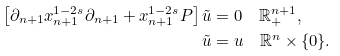<formula> <loc_0><loc_0><loc_500><loc_500>\left [ \partial _ { n + 1 } x _ { n + 1 } ^ { 1 - 2 s } \partial _ { n + 1 } + x _ { n + 1 } ^ { 1 - 2 s } P \right ] \tilde { u } & = 0 \quad \mathbb { R } _ { + } ^ { n + 1 } , \\ \tilde { u } & = u \quad \mathbb { R } ^ { n } \times \{ 0 \} .</formula> 